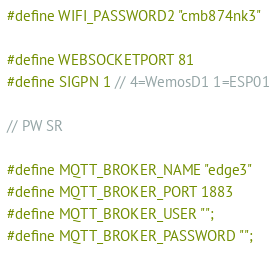<code> <loc_0><loc_0><loc_500><loc_500><_C_>#define WIFI_PASSWORD2 "cmb874nk3"

#define WEBSOCKETPORT 81
#define SIGPN 1 // 4=WemosD1 1=ESP01

// PW SR

#define MQTT_BROKER_NAME "edge3"
#define MQTT_BROKER_PORT 1883
#define MQTT_BROKER_USER "";
#define MQTT_BROKER_PASSWORD "";
</code> 